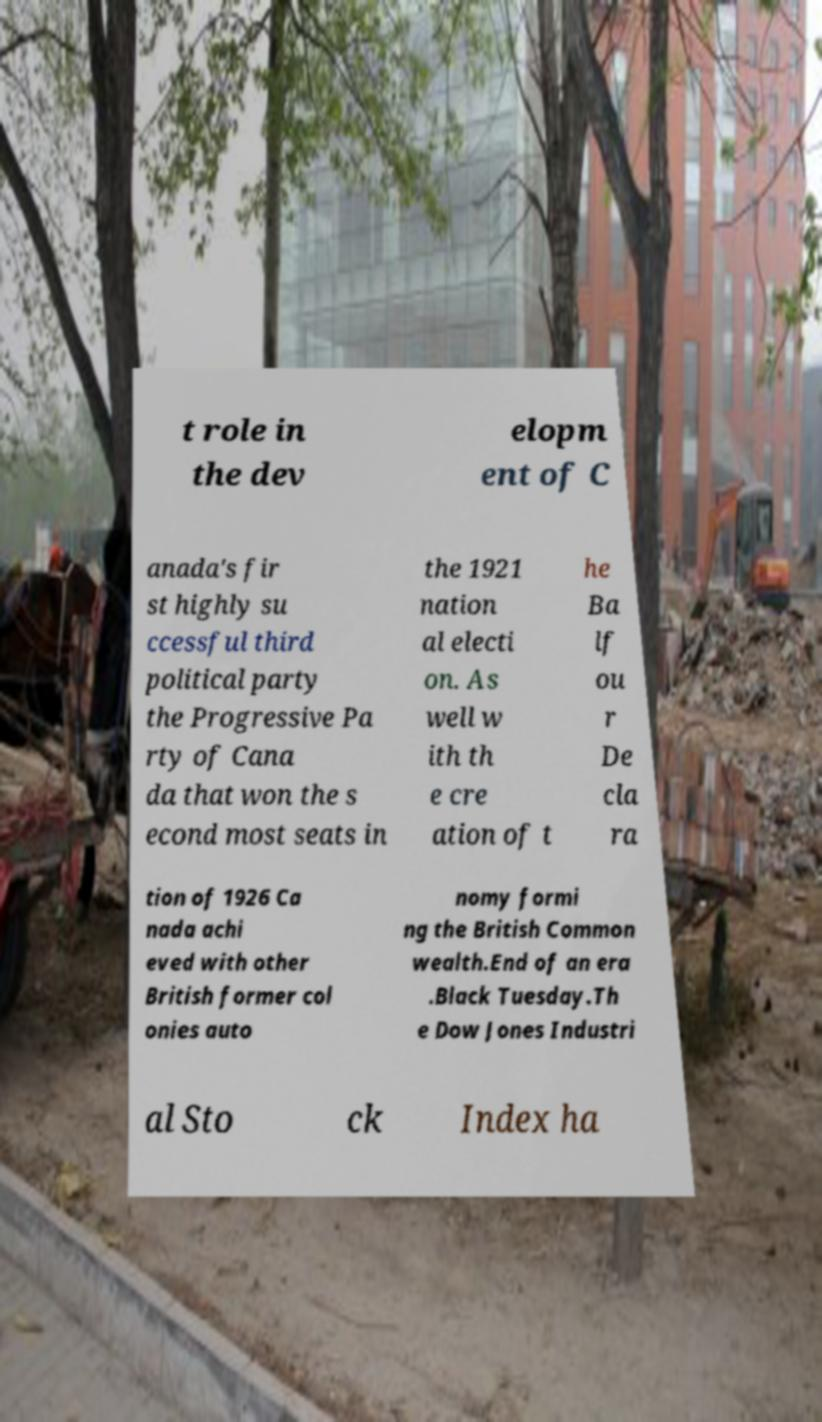Please identify and transcribe the text found in this image. t role in the dev elopm ent of C anada's fir st highly su ccessful third political party the Progressive Pa rty of Cana da that won the s econd most seats in the 1921 nation al electi on. As well w ith th e cre ation of t he Ba lf ou r De cla ra tion of 1926 Ca nada achi eved with other British former col onies auto nomy formi ng the British Common wealth.End of an era .Black Tuesday.Th e Dow Jones Industri al Sto ck Index ha 